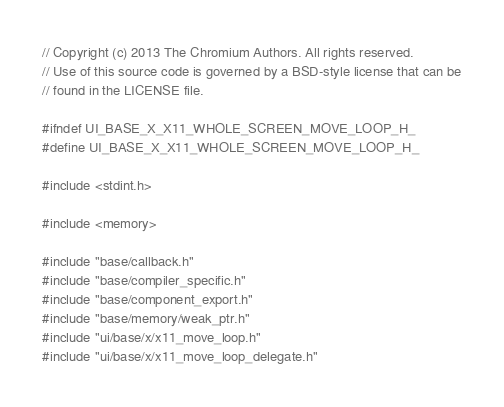Convert code to text. <code><loc_0><loc_0><loc_500><loc_500><_C_>// Copyright (c) 2013 The Chromium Authors. All rights reserved.
// Use of this source code is governed by a BSD-style license that can be
// found in the LICENSE file.

#ifndef UI_BASE_X_X11_WHOLE_SCREEN_MOVE_LOOP_H_
#define UI_BASE_X_X11_WHOLE_SCREEN_MOVE_LOOP_H_

#include <stdint.h>

#include <memory>

#include "base/callback.h"
#include "base/compiler_specific.h"
#include "base/component_export.h"
#include "base/memory/weak_ptr.h"
#include "ui/base/x/x11_move_loop.h"
#include "ui/base/x/x11_move_loop_delegate.h"</code> 